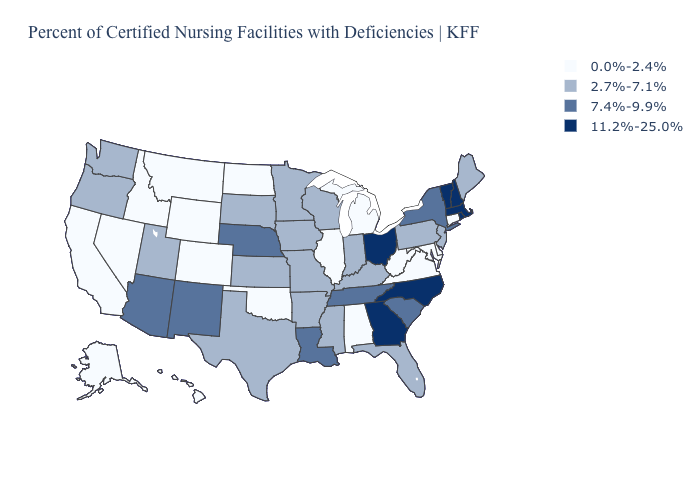Name the states that have a value in the range 11.2%-25.0%?
Concise answer only. Georgia, Massachusetts, New Hampshire, North Carolina, Ohio, Rhode Island, Vermont. Name the states that have a value in the range 0.0%-2.4%?
Answer briefly. Alabama, Alaska, California, Colorado, Connecticut, Delaware, Hawaii, Idaho, Illinois, Maryland, Michigan, Montana, Nevada, North Dakota, Oklahoma, Virginia, West Virginia, Wyoming. Does the first symbol in the legend represent the smallest category?
Keep it brief. Yes. What is the highest value in states that border Texas?
Quick response, please. 7.4%-9.9%. Among the states that border North Dakota , which have the lowest value?
Quick response, please. Montana. Name the states that have a value in the range 7.4%-9.9%?
Give a very brief answer. Arizona, Louisiana, Nebraska, New Mexico, New York, South Carolina, Tennessee. Which states have the lowest value in the USA?
Give a very brief answer. Alabama, Alaska, California, Colorado, Connecticut, Delaware, Hawaii, Idaho, Illinois, Maryland, Michigan, Montana, Nevada, North Dakota, Oklahoma, Virginia, West Virginia, Wyoming. Is the legend a continuous bar?
Quick response, please. No. What is the highest value in states that border Illinois?
Give a very brief answer. 2.7%-7.1%. What is the value of North Dakota?
Give a very brief answer. 0.0%-2.4%. Name the states that have a value in the range 2.7%-7.1%?
Concise answer only. Arkansas, Florida, Indiana, Iowa, Kansas, Kentucky, Maine, Minnesota, Mississippi, Missouri, New Jersey, Oregon, Pennsylvania, South Dakota, Texas, Utah, Washington, Wisconsin. Does Wisconsin have the highest value in the USA?
Be succinct. No. Does the first symbol in the legend represent the smallest category?
Short answer required. Yes. Does West Virginia have the lowest value in the South?
Give a very brief answer. Yes. What is the value of Pennsylvania?
Keep it brief. 2.7%-7.1%. 